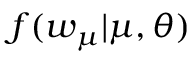<formula> <loc_0><loc_0><loc_500><loc_500>f ( w _ { \mu } | \mu , \theta )</formula> 